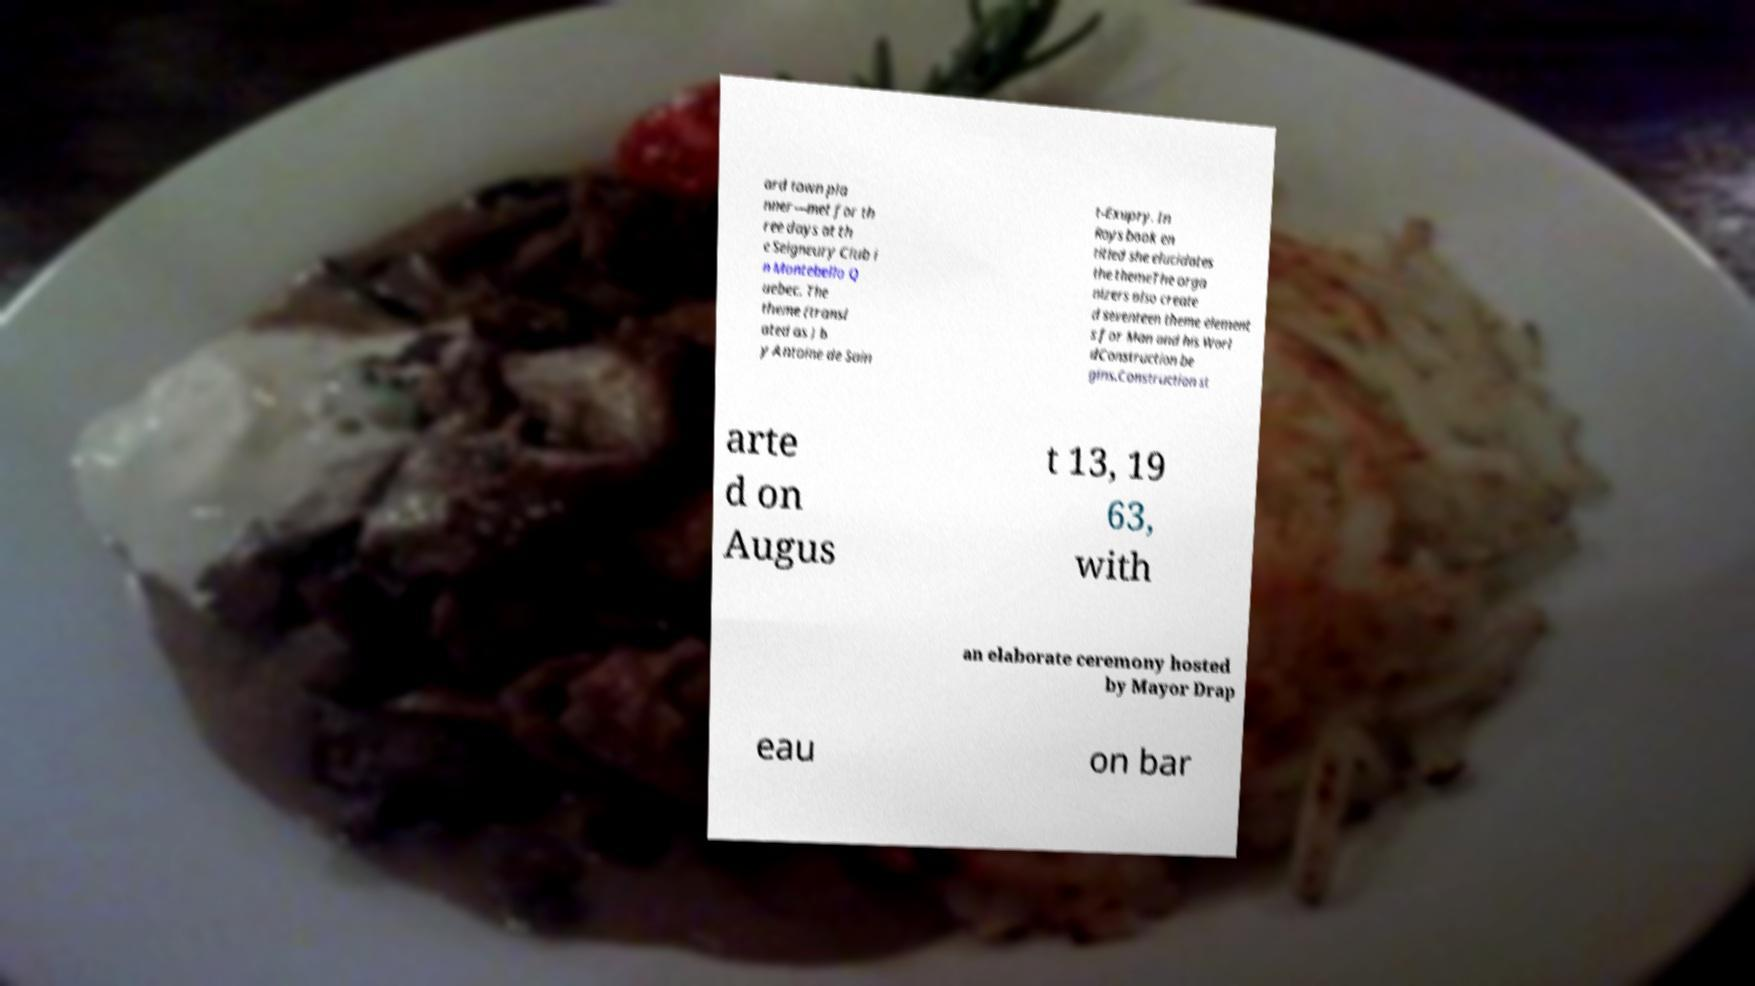There's text embedded in this image that I need extracted. Can you transcribe it verbatim? ard town pla nner—met for th ree days at th e Seigneury Club i n Montebello Q uebec. The theme (transl ated as ) b y Antoine de Sain t-Exupry. In Roys book en titled she elucidates the themeThe orga nizers also create d seventeen theme element s for Man and his Worl dConstruction be gins.Construction st arte d on Augus t 13, 19 63, with an elaborate ceremony hosted by Mayor Drap eau on bar 